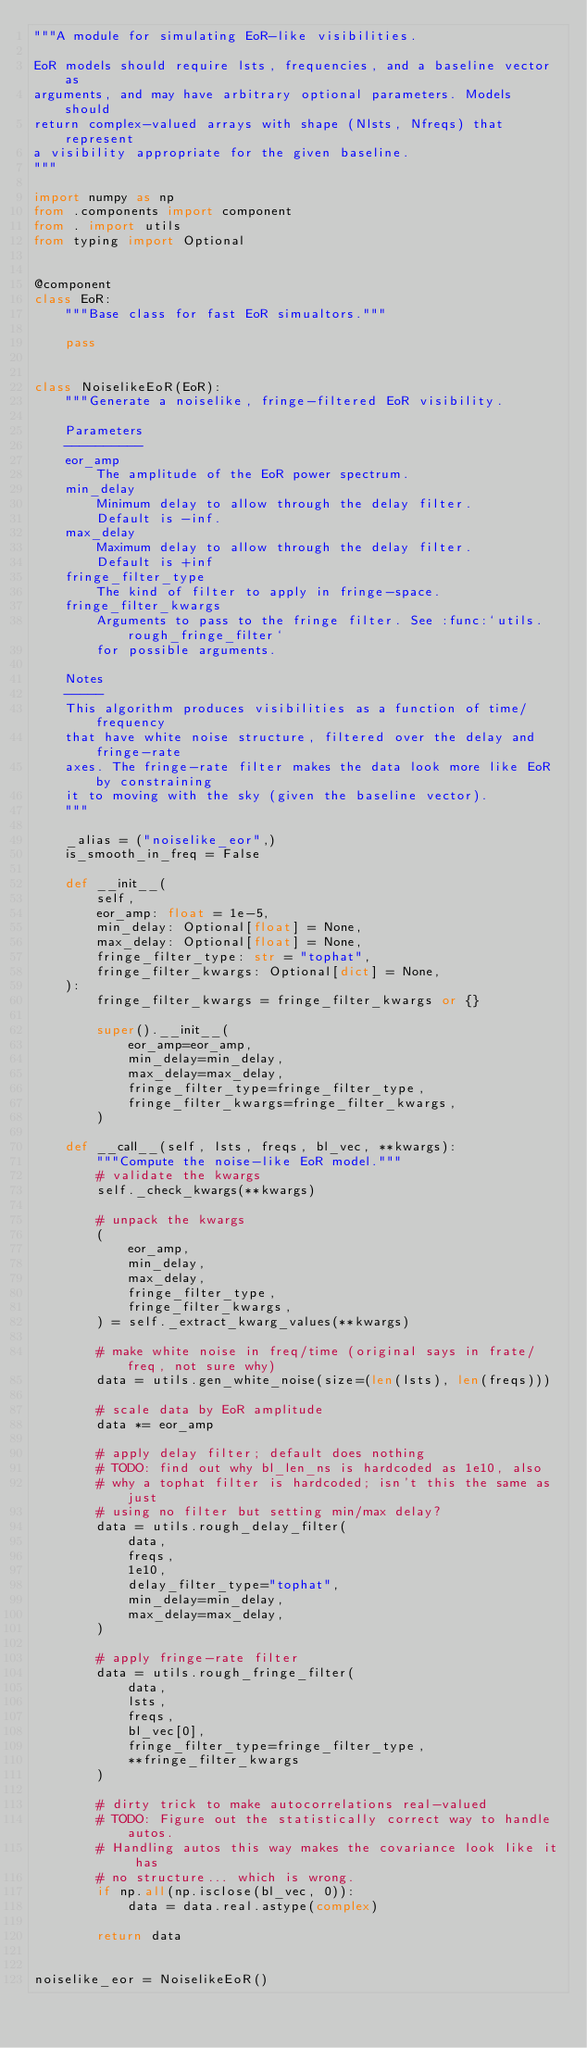<code> <loc_0><loc_0><loc_500><loc_500><_Python_>"""A module for simulating EoR-like visibilities.

EoR models should require lsts, frequencies, and a baseline vector as
arguments, and may have arbitrary optional parameters. Models should
return complex-valued arrays with shape (Nlsts, Nfreqs) that represent
a visibility appropriate for the given baseline.
"""

import numpy as np
from .components import component
from . import utils
from typing import Optional


@component
class EoR:
    """Base class for fast EoR simualtors."""

    pass


class NoiselikeEoR(EoR):
    """Generate a noiselike, fringe-filtered EoR visibility.

    Parameters
    ----------
    eor_amp
        The amplitude of the EoR power spectrum.
    min_delay
        Minimum delay to allow through the delay filter.
        Default is -inf.
    max_delay
        Maximum delay to allow through the delay filter.
        Default is +inf
    fringe_filter_type
        The kind of filter to apply in fringe-space.
    fringe_filter_kwargs
        Arguments to pass to the fringe filter. See :func:`utils.rough_fringe_filter`
        for possible arguments.

    Notes
    -----
    This algorithm produces visibilities as a function of time/frequency
    that have white noise structure, filtered over the delay and fringe-rate
    axes. The fringe-rate filter makes the data look more like EoR by constraining
    it to moving with the sky (given the baseline vector).
    """

    _alias = ("noiselike_eor",)
    is_smooth_in_freq = False

    def __init__(
        self,
        eor_amp: float = 1e-5,
        min_delay: Optional[float] = None,
        max_delay: Optional[float] = None,
        fringe_filter_type: str = "tophat",
        fringe_filter_kwargs: Optional[dict] = None,
    ):
        fringe_filter_kwargs = fringe_filter_kwargs or {}

        super().__init__(
            eor_amp=eor_amp,
            min_delay=min_delay,
            max_delay=max_delay,
            fringe_filter_type=fringe_filter_type,
            fringe_filter_kwargs=fringe_filter_kwargs,
        )

    def __call__(self, lsts, freqs, bl_vec, **kwargs):
        """Compute the noise-like EoR model."""
        # validate the kwargs
        self._check_kwargs(**kwargs)

        # unpack the kwargs
        (
            eor_amp,
            min_delay,
            max_delay,
            fringe_filter_type,
            fringe_filter_kwargs,
        ) = self._extract_kwarg_values(**kwargs)

        # make white noise in freq/time (original says in frate/freq, not sure why)
        data = utils.gen_white_noise(size=(len(lsts), len(freqs)))

        # scale data by EoR amplitude
        data *= eor_amp

        # apply delay filter; default does nothing
        # TODO: find out why bl_len_ns is hardcoded as 1e10, also
        # why a tophat filter is hardcoded; isn't this the same as just
        # using no filter but setting min/max delay?
        data = utils.rough_delay_filter(
            data,
            freqs,
            1e10,
            delay_filter_type="tophat",
            min_delay=min_delay,
            max_delay=max_delay,
        )

        # apply fringe-rate filter
        data = utils.rough_fringe_filter(
            data,
            lsts,
            freqs,
            bl_vec[0],
            fringe_filter_type=fringe_filter_type,
            **fringe_filter_kwargs
        )

        # dirty trick to make autocorrelations real-valued
        # TODO: Figure out the statistically correct way to handle autos.
        # Handling autos this way makes the covariance look like it has
        # no structure... which is wrong.
        if np.all(np.isclose(bl_vec, 0)):
            data = data.real.astype(complex)

        return data


noiselike_eor = NoiselikeEoR()
</code> 